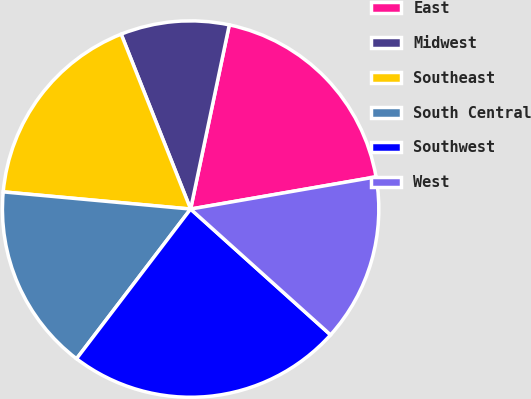<chart> <loc_0><loc_0><loc_500><loc_500><pie_chart><fcel>East<fcel>Midwest<fcel>Southeast<fcel>South Central<fcel>Southwest<fcel>West<nl><fcel>18.97%<fcel>9.31%<fcel>17.53%<fcel>16.09%<fcel>23.71%<fcel>14.39%<nl></chart> 